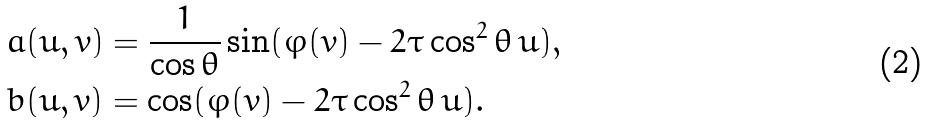Convert formula to latex. <formula><loc_0><loc_0><loc_500><loc_500>& a ( u , v ) = \frac { 1 } { \cos \theta } \sin ( \varphi ( v ) - 2 \tau \cos ^ { 2 } \theta \, u ) , \\ & b ( u , v ) = \cos ( \varphi ( v ) - 2 \tau \cos ^ { 2 } \theta \, u ) .</formula> 